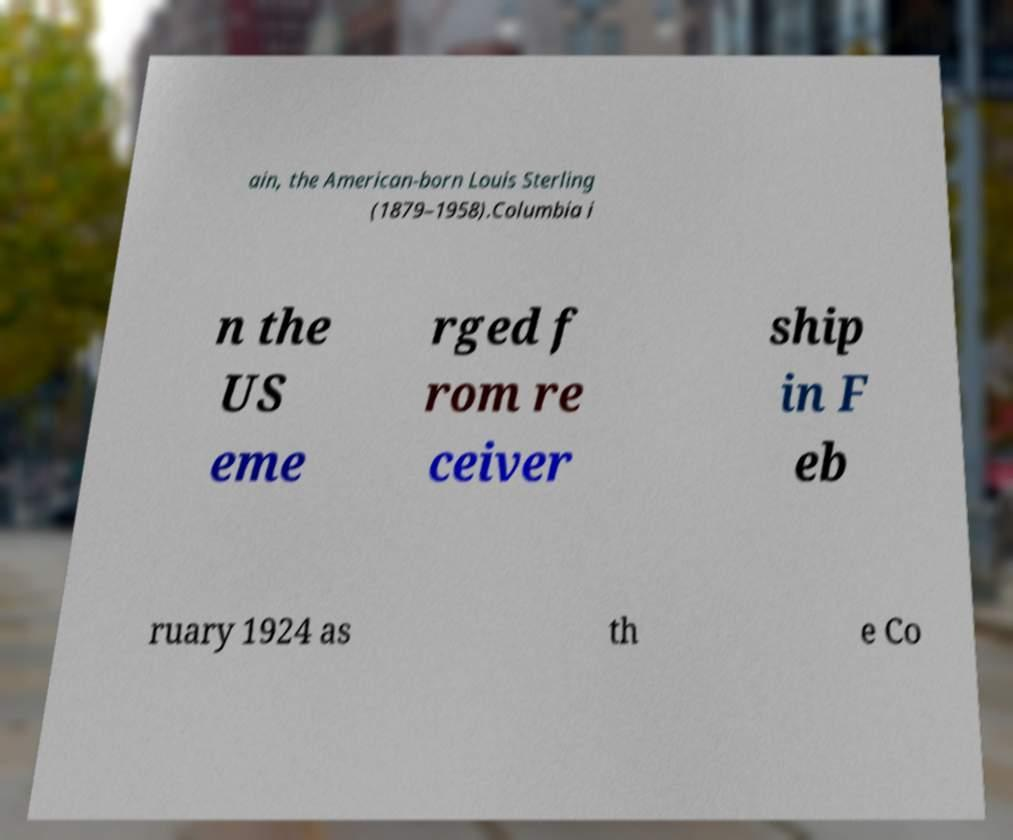What messages or text are displayed in this image? I need them in a readable, typed format. ain, the American-born Louis Sterling (1879–1958).Columbia i n the US eme rged f rom re ceiver ship in F eb ruary 1924 as th e Co 